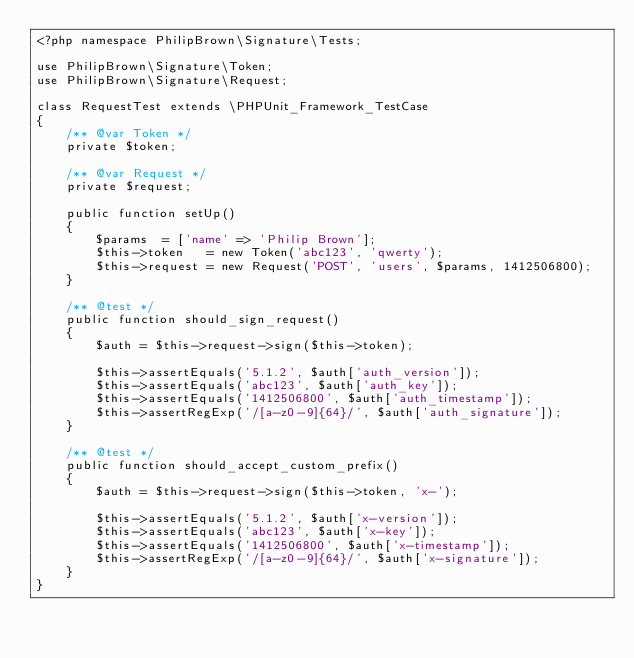<code> <loc_0><loc_0><loc_500><loc_500><_PHP_><?php namespace PhilipBrown\Signature\Tests;

use PhilipBrown\Signature\Token;
use PhilipBrown\Signature\Request;

class RequestTest extends \PHPUnit_Framework_TestCase
{
    /** @var Token */
    private $token;

    /** @var Request */
    private $request;

    public function setUp()
    {
        $params  = ['name' => 'Philip Brown'];
        $this->token   = new Token('abc123', 'qwerty');
        $this->request = new Request('POST', 'users', $params, 1412506800);
    }

    /** @test */
    public function should_sign_request()
    {
        $auth = $this->request->sign($this->token);

        $this->assertEquals('5.1.2', $auth['auth_version']);
        $this->assertEquals('abc123', $auth['auth_key']);
        $this->assertEquals('1412506800', $auth['auth_timestamp']);
        $this->assertRegExp('/[a-z0-9]{64}/', $auth['auth_signature']);
    }

    /** @test */
    public function should_accept_custom_prefix()
    {
        $auth = $this->request->sign($this->token, 'x-');

        $this->assertEquals('5.1.2', $auth['x-version']);
        $this->assertEquals('abc123', $auth['x-key']);
        $this->assertEquals('1412506800', $auth['x-timestamp']);
        $this->assertRegExp('/[a-z0-9]{64}/', $auth['x-signature']);
    }
}
</code> 